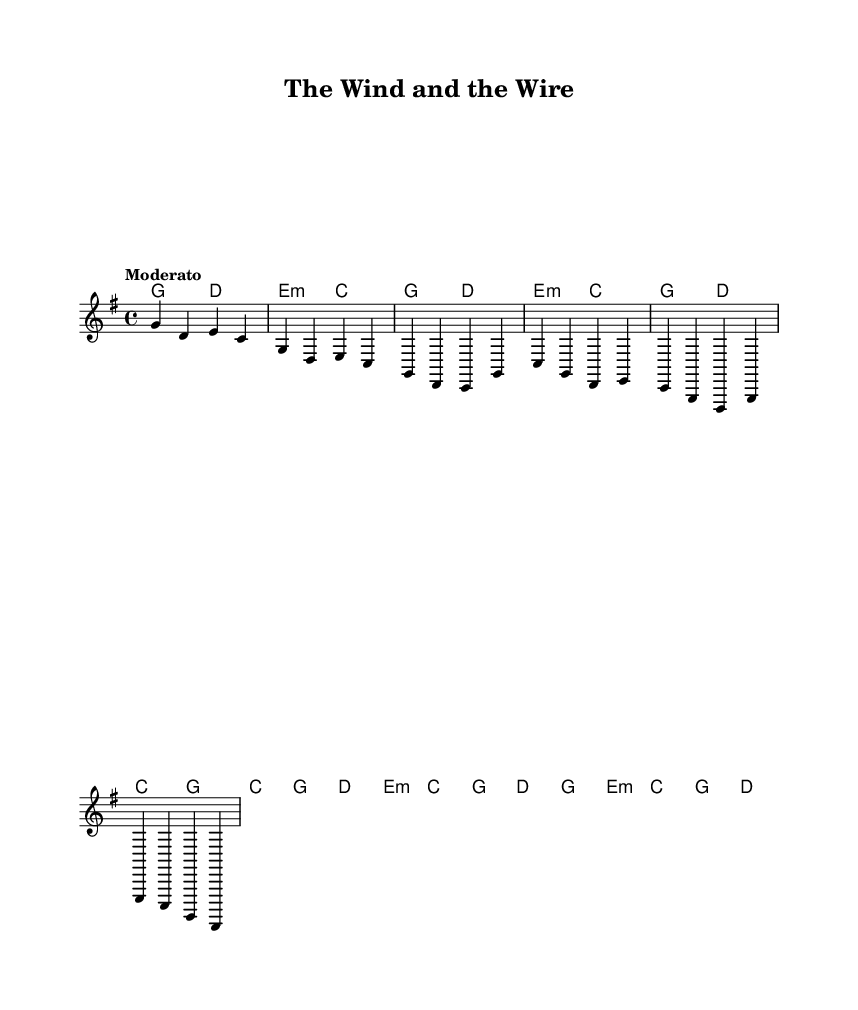What is the key signature of this music? The key signature is G major, which has one sharp (F#). This can be observed in the key signature indication at the beginning of the staff.
Answer: G major What is the time signature of this music? The time signature is 4/4, which indicates that there are four beats in each measure and the quarter note gets the beat. This is displayed at the beginning of the score.
Answer: 4/4 What is the tempo marking for this piece? The tempo marking is Moderato, which suggests a moderately fast pace. This appears at the beginning under the time signature.
Answer: Moderato How many measures are present in the chorus? The chorus consists of four measures, as determined by counting the measures in the section labeled as the chorus in the score.
Answer: 4 What is the chord progression used in the intro? The chord progression in the intro is G, D, E minor, C. This can be deduced from the chord changes indicated above the melody line for the intro section.
Answer: G, D, E minor, C How many different chords are used in the chorus? There are three unique chords used in the chorus: C, G, and D. These can be noted by looking at the chord indicators above the melody for the chorus section.
Answer: 3 What characteristic typically defines folk music, evident in this piece? A characteristic that typically defines folk music is storytelling or themes relevant to rural life, which can be inferred from the title "The Wind and the Wire" and its potential subject matter.
Answer: Storytelling 